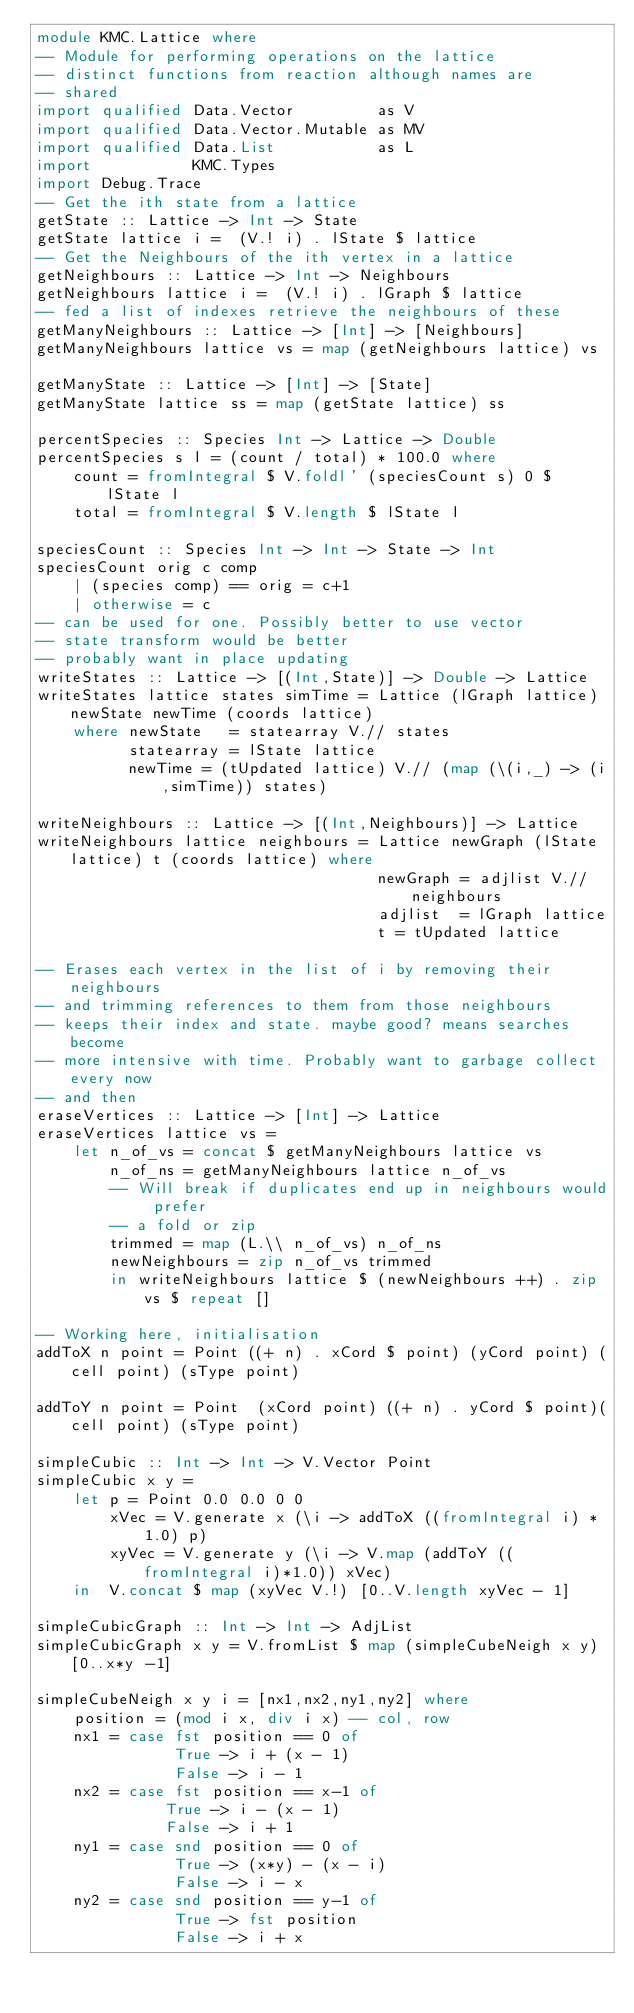Convert code to text. <code><loc_0><loc_0><loc_500><loc_500><_Haskell_>module KMC.Lattice where
-- Module for performing operations on the lattice
-- distinct functions from reaction although names are
-- shared
import qualified Data.Vector         as V
import qualified Data.Vector.Mutable as MV
import qualified Data.List           as L
import           KMC.Types
import Debug.Trace
-- Get the ith state from a lattice
getState :: Lattice -> Int -> State
getState lattice i =  (V.! i) . lState $ lattice
-- Get the Neighbours of the ith vertex in a lattice
getNeighbours :: Lattice -> Int -> Neighbours
getNeighbours lattice i =  (V.! i) . lGraph $ lattice
-- fed a list of indexes retrieve the neighbours of these
getManyNeighbours :: Lattice -> [Int] -> [Neighbours]
getManyNeighbours lattice vs = map (getNeighbours lattice) vs

getManyState :: Lattice -> [Int] -> [State]
getManyState lattice ss = map (getState lattice) ss

percentSpecies :: Species Int -> Lattice -> Double
percentSpecies s l = (count / total) * 100.0 where
    count = fromIntegral $ V.foldl' (speciesCount s) 0 $ lState l
    total = fromIntegral $ V.length $ lState l

speciesCount :: Species Int -> Int -> State -> Int
speciesCount orig c comp
    | (species comp) == orig = c+1
    | otherwise = c
-- can be used for one. Possibly better to use vector
-- state transform would be better
-- probably want in place updating
writeStates :: Lattice -> [(Int,State)] -> Double -> Lattice
writeStates lattice states simTime = Lattice (lGraph lattice) newState newTime (coords lattice)
    where newState   = statearray V.// states
          statearray = lState lattice
          newTime = (tUpdated lattice) V.// (map (\(i,_) -> (i,simTime)) states)

writeNeighbours :: Lattice -> [(Int,Neighbours)] -> Lattice
writeNeighbours lattice neighbours = Lattice newGraph (lState lattice) t (coords lattice) where
                                     newGraph = adjlist V.// neighbours
                                     adjlist  = lGraph lattice
                                     t = tUpdated lattice

-- Erases each vertex in the list of i by removing their neighbours
-- and trimming references to them from those neighbours
-- keeps their index and state. maybe good? means searches become
-- more intensive with time. Probably want to garbage collect every now
-- and then
eraseVertices :: Lattice -> [Int] -> Lattice
eraseVertices lattice vs = 
    let n_of_vs = concat $ getManyNeighbours lattice vs 
        n_of_ns = getManyNeighbours lattice n_of_vs 
        -- Will break if duplicates end up in neighbours would prefer
        -- a fold or zip
        trimmed = map (L.\\ n_of_vs) n_of_ns
        newNeighbours = zip n_of_vs trimmed
        in writeNeighbours lattice $ (newNeighbours ++) . zip vs $ repeat []

-- Working here, initialisation
addToX n point = Point ((+ n) . xCord $ point) (yCord point) (cell point) (sType point)

addToY n point = Point  (xCord point) ((+ n) . yCord $ point)(cell point) (sType point)

simpleCubic :: Int -> Int -> V.Vector Point
simpleCubic x y =
    let p = Point 0.0 0.0 0 0
        xVec = V.generate x (\i -> addToX ((fromIntegral i) * 1.0) p)
        xyVec = V.generate y (\i -> V.map (addToY ((fromIntegral i)*1.0)) xVec)
    in  V.concat $ map (xyVec V.!) [0..V.length xyVec - 1]

simpleCubicGraph :: Int -> Int -> AdjList
simpleCubicGraph x y = V.fromList $ map (simpleCubeNeigh x y) [0..x*y -1]

simpleCubeNeigh x y i = [nx1,nx2,ny1,ny2] where
    position = (mod i x, div i x) -- col, row
    nx1 = case fst position == 0 of
               True -> i + (x - 1)
               False -> i - 1
    nx2 = case fst position == x-1 of
              True -> i - (x - 1)
              False -> i + 1
    ny1 = case snd position == 0 of
               True -> (x*y) - (x - i)
               False -> i - x
    ny2 = case snd position == y-1 of
               True -> fst position
               False -> i + x
</code> 